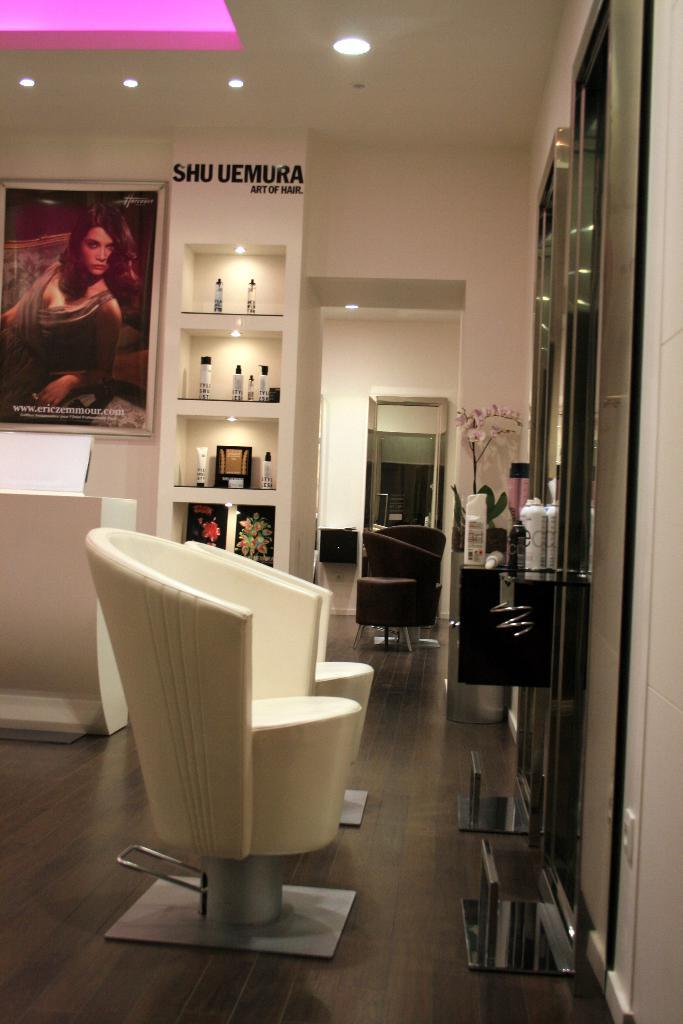What type of furniture is on the floor in the image? There are chairs on the floor in the image. What can be seen on the shelves in the image? There are bottles on the shelves in the image. What type of reflective surface is present in the image? There are mirrors in the image. What is hanging on the wall in the image? There is a poster on the wall in the image. What part of the room is visible from the image? The ceiling is visible in the image. What type of lighting is present in the image? There are lights in the image. What type of plant is present in the image? There is a plant with flowers in the image. Can you describe the unspecified objects in the image? Unfortunately, the facts provided do not specify the nature of the unspecified objects in the image. How does the fold in the image contribute to the experience of the room? There is no fold present in the image, so it cannot contribute to the experience of the room. What type of hole is visible in the image? There is no hole present in the image. 